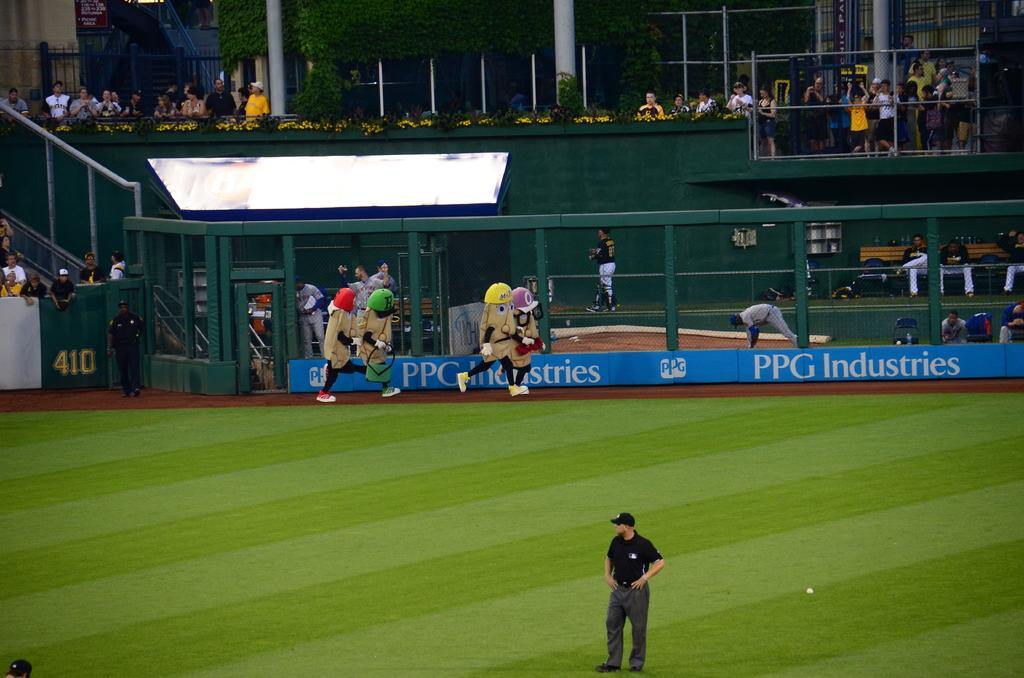<image>
Share a concise interpretation of the image provided. A baseball field with four mascots that look like potatoes in hats running next to the PPG Industries banner 